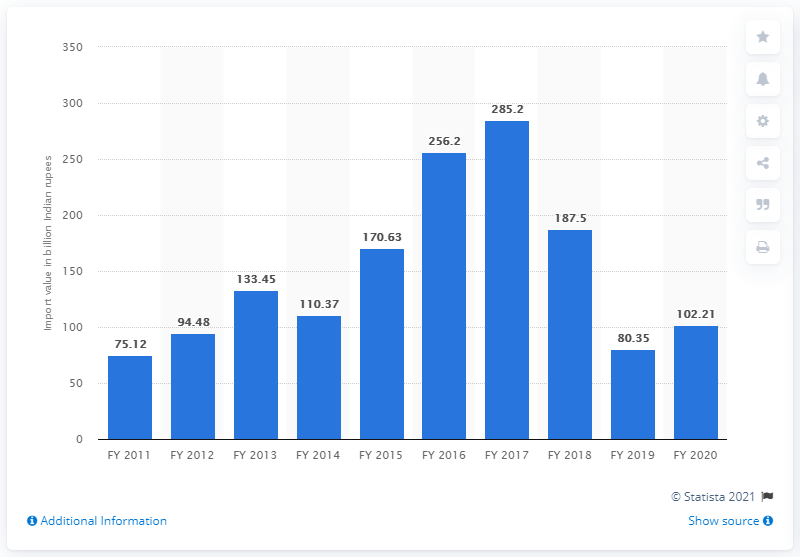Highlight a few significant elements in this photo. India imported pulses worth 102.21 billion Indian rupees in the financial year 2020. 